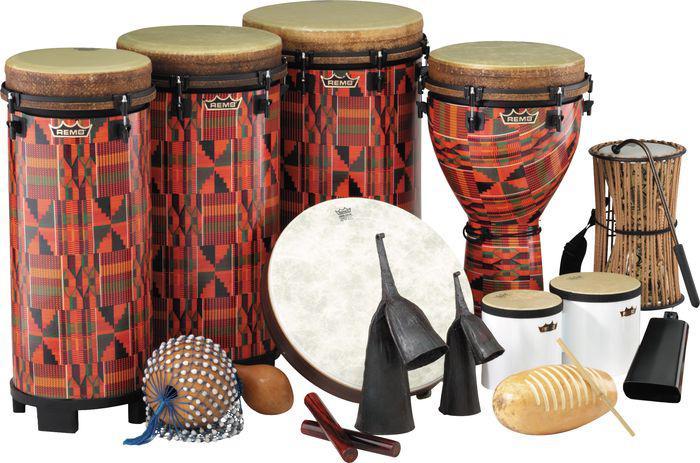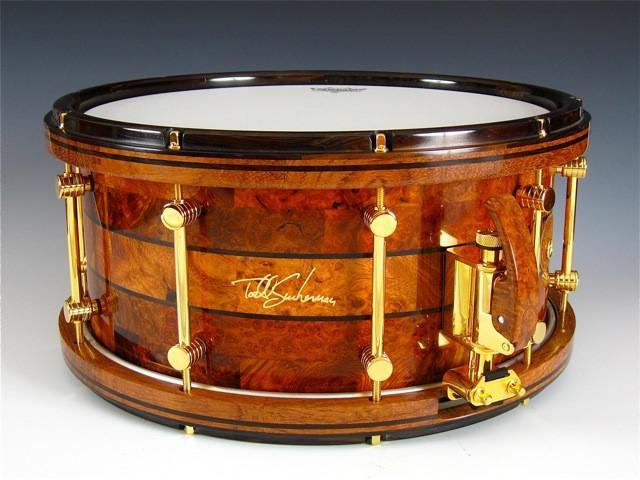The first image is the image on the left, the second image is the image on the right. Assess this claim about the two images: "One image shows a single drum while the other shows drums along with other types of instruments.". Correct or not? Answer yes or no. Yes. The first image is the image on the left, the second image is the image on the right. Evaluate the accuracy of this statement regarding the images: "There is more than one type of instrument.". Is it true? Answer yes or no. Yes. 